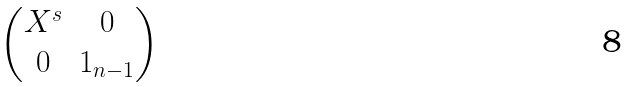Convert formula to latex. <formula><loc_0><loc_0><loc_500><loc_500>\begin{pmatrix} X ^ { s } & 0 \\ 0 & 1 _ { n - 1 } \end{pmatrix}</formula> 